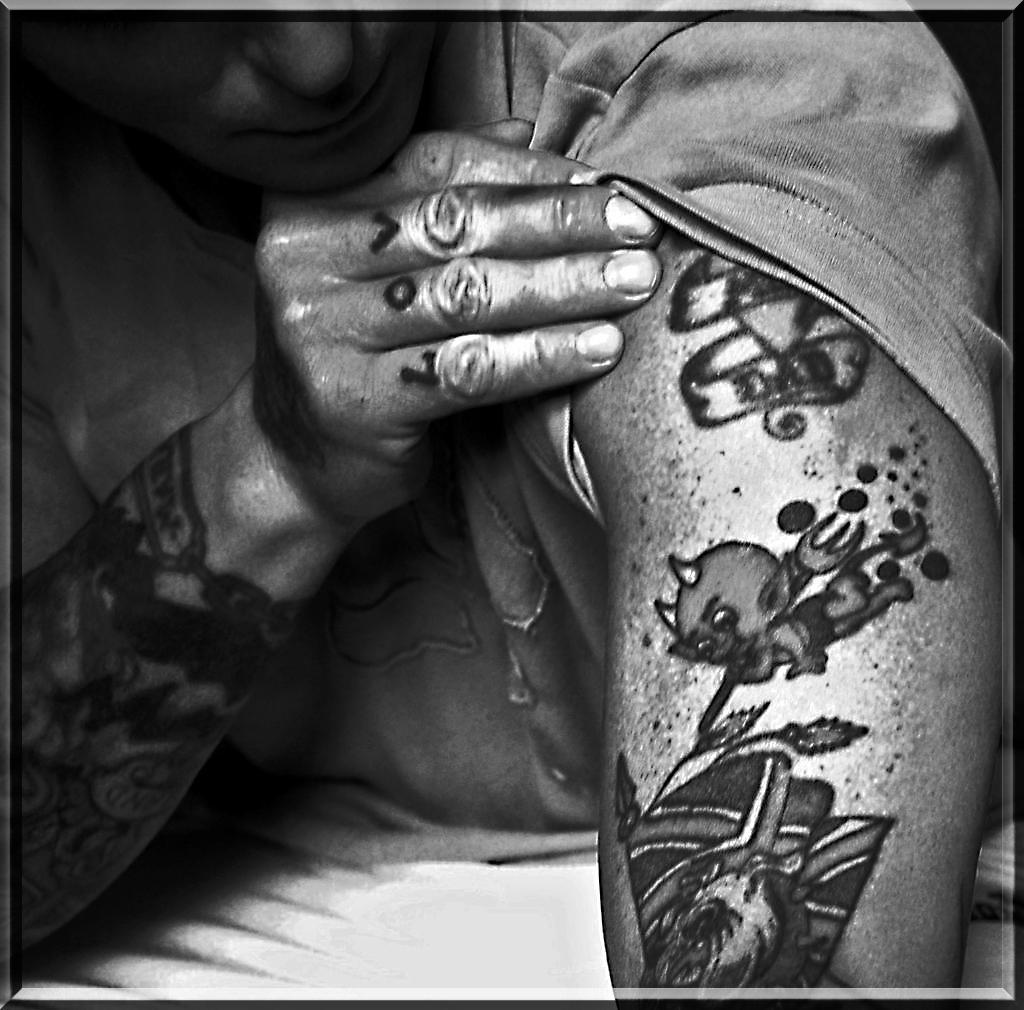Please provide a concise description of this image. In this picture we can see tattoos on the hands, and it is a black and white photography. 